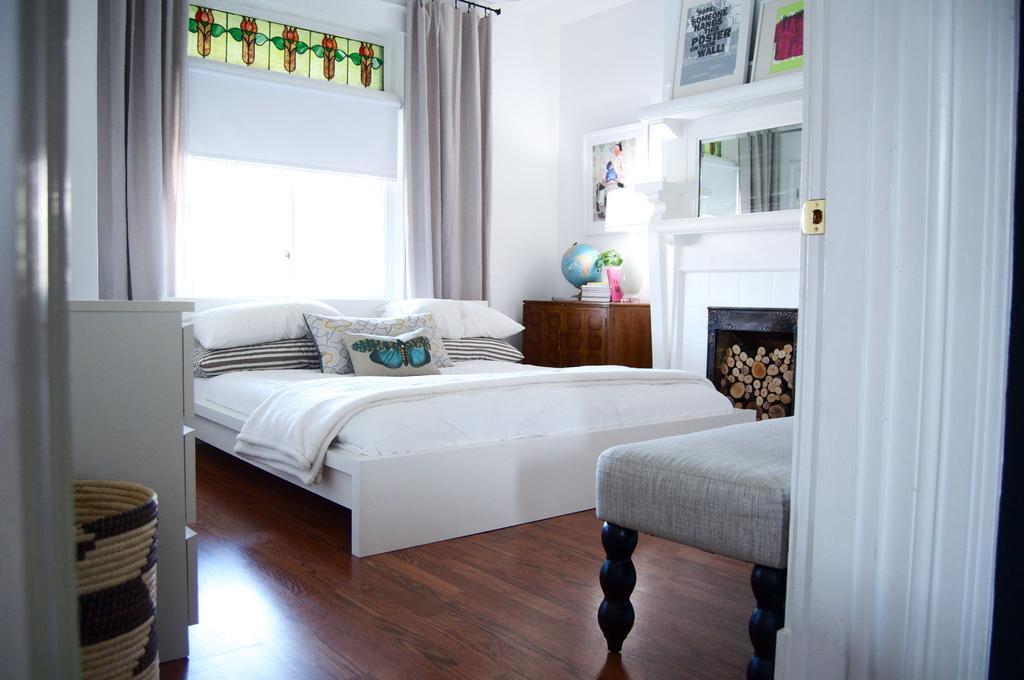Please provide a concise description of this image. This picture shows an inner view of a bedroom we see a bed and few pillows and photo frames on the wall 